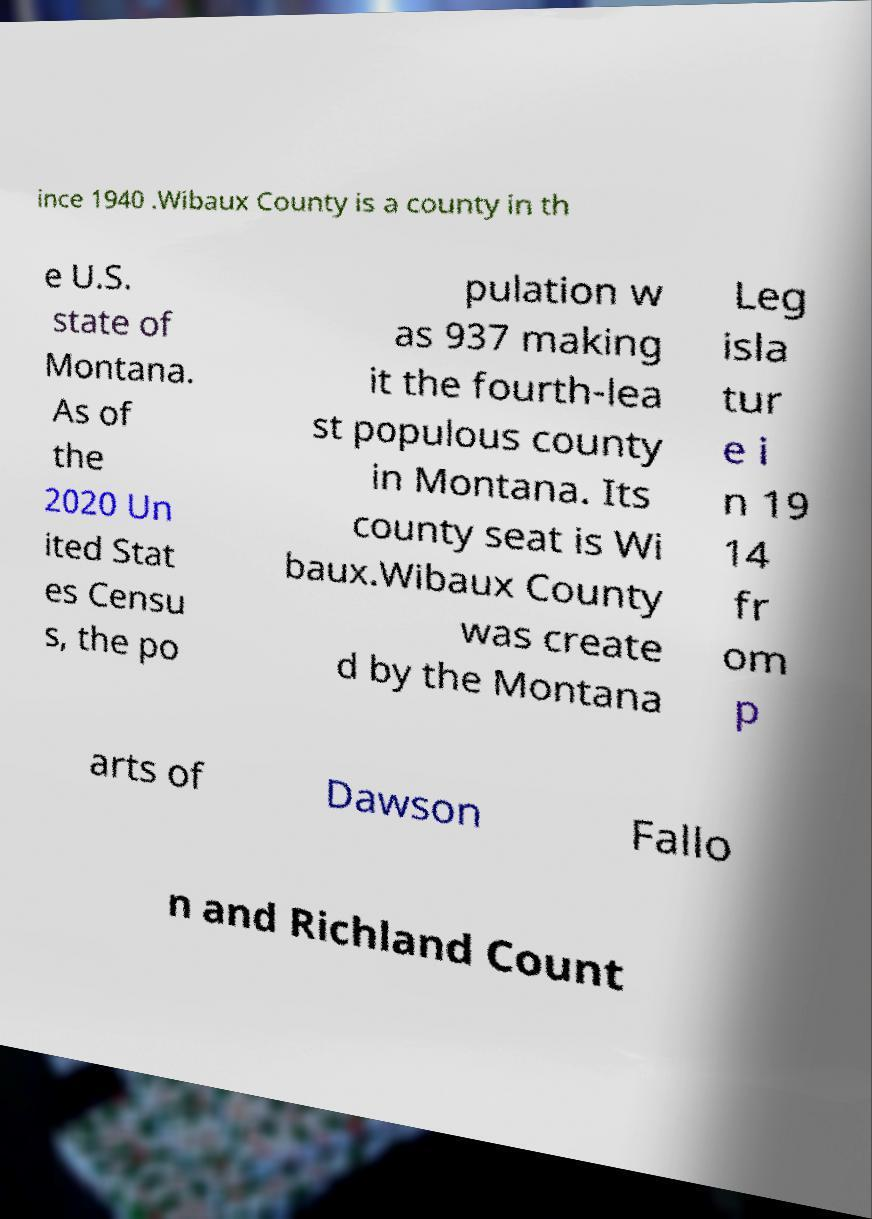Could you extract and type out the text from this image? ince 1940 .Wibaux County is a county in th e U.S. state of Montana. As of the 2020 Un ited Stat es Censu s, the po pulation w as 937 making it the fourth-lea st populous county in Montana. Its county seat is Wi baux.Wibaux County was create d by the Montana Leg isla tur e i n 19 14 fr om p arts of Dawson Fallo n and Richland Count 